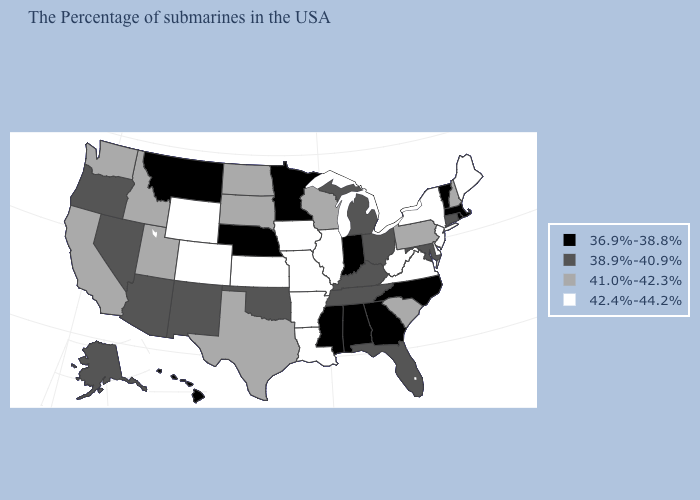Which states hav the highest value in the South?
Quick response, please. Delaware, Virginia, West Virginia, Louisiana, Arkansas. Does the map have missing data?
Give a very brief answer. No. How many symbols are there in the legend?
Answer briefly. 4. Name the states that have a value in the range 42.4%-44.2%?
Concise answer only. Maine, New York, New Jersey, Delaware, Virginia, West Virginia, Illinois, Louisiana, Missouri, Arkansas, Iowa, Kansas, Wyoming, Colorado. Name the states that have a value in the range 36.9%-38.8%?
Write a very short answer. Massachusetts, Rhode Island, Vermont, North Carolina, Georgia, Indiana, Alabama, Mississippi, Minnesota, Nebraska, Montana, Hawaii. Which states hav the highest value in the West?
Keep it brief. Wyoming, Colorado. What is the value of New Mexico?
Short answer required. 38.9%-40.9%. Does the map have missing data?
Give a very brief answer. No. Does Idaho have the lowest value in the USA?
Keep it brief. No. Name the states that have a value in the range 36.9%-38.8%?
Give a very brief answer. Massachusetts, Rhode Island, Vermont, North Carolina, Georgia, Indiana, Alabama, Mississippi, Minnesota, Nebraska, Montana, Hawaii. What is the value of Alabama?
Write a very short answer. 36.9%-38.8%. What is the highest value in states that border Maryland?
Short answer required. 42.4%-44.2%. Among the states that border Missouri , does Kentucky have the lowest value?
Concise answer only. No. What is the lowest value in states that border Maine?
Give a very brief answer. 41.0%-42.3%. What is the value of Nebraska?
Write a very short answer. 36.9%-38.8%. 